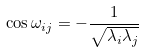<formula> <loc_0><loc_0><loc_500><loc_500>\cos \omega _ { i j } = - \frac { 1 } { \sqrt { \lambda _ { i } \lambda _ { j } } }</formula> 